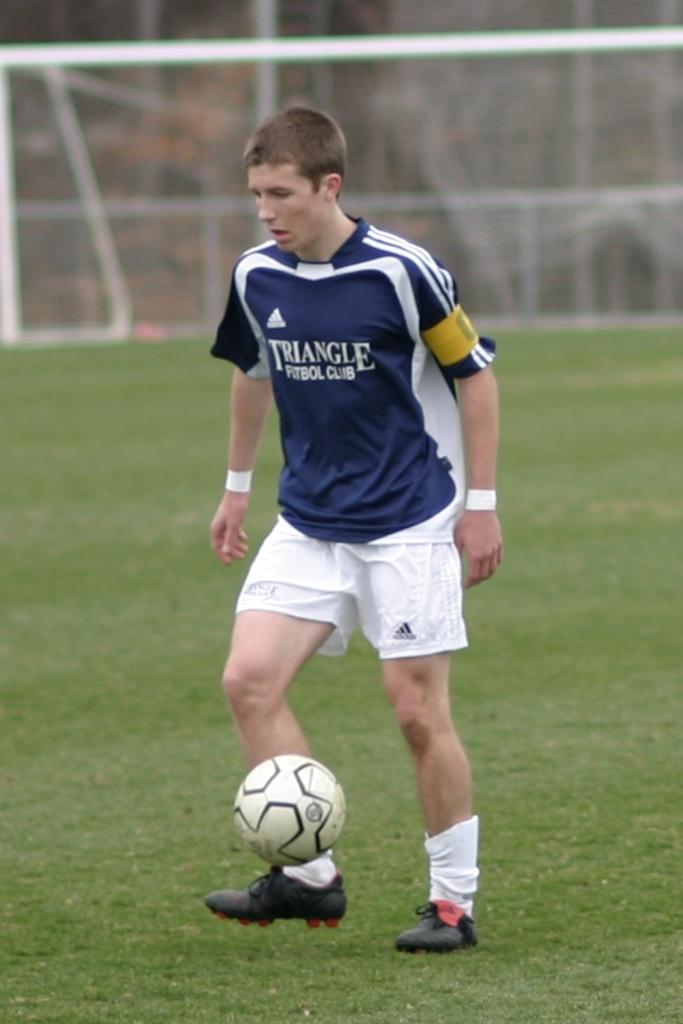<image>
Offer a succinct explanation of the picture presented. A soccer player wearing the jersey of Triangle Football Club lifts his foot to kick the ball. 